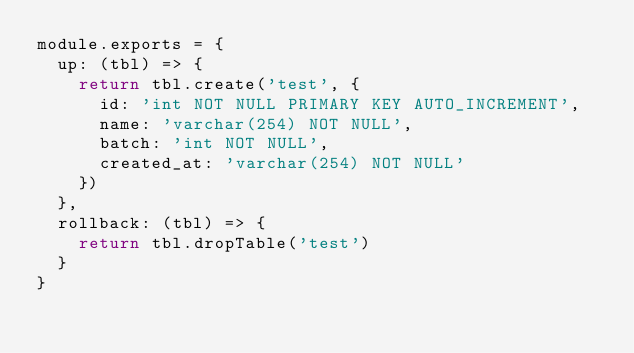<code> <loc_0><loc_0><loc_500><loc_500><_JavaScript_>module.exports = {
  up: (tbl) => {
    return tbl.create('test', {
      id: 'int NOT NULL PRIMARY KEY AUTO_INCREMENT',
      name: 'varchar(254) NOT NULL',
      batch: 'int NOT NULL',
      created_at: 'varchar(254) NOT NULL'
    })
  },
  rollback: (tbl) => {
    return tbl.dropTable('test')
  }
}
</code> 